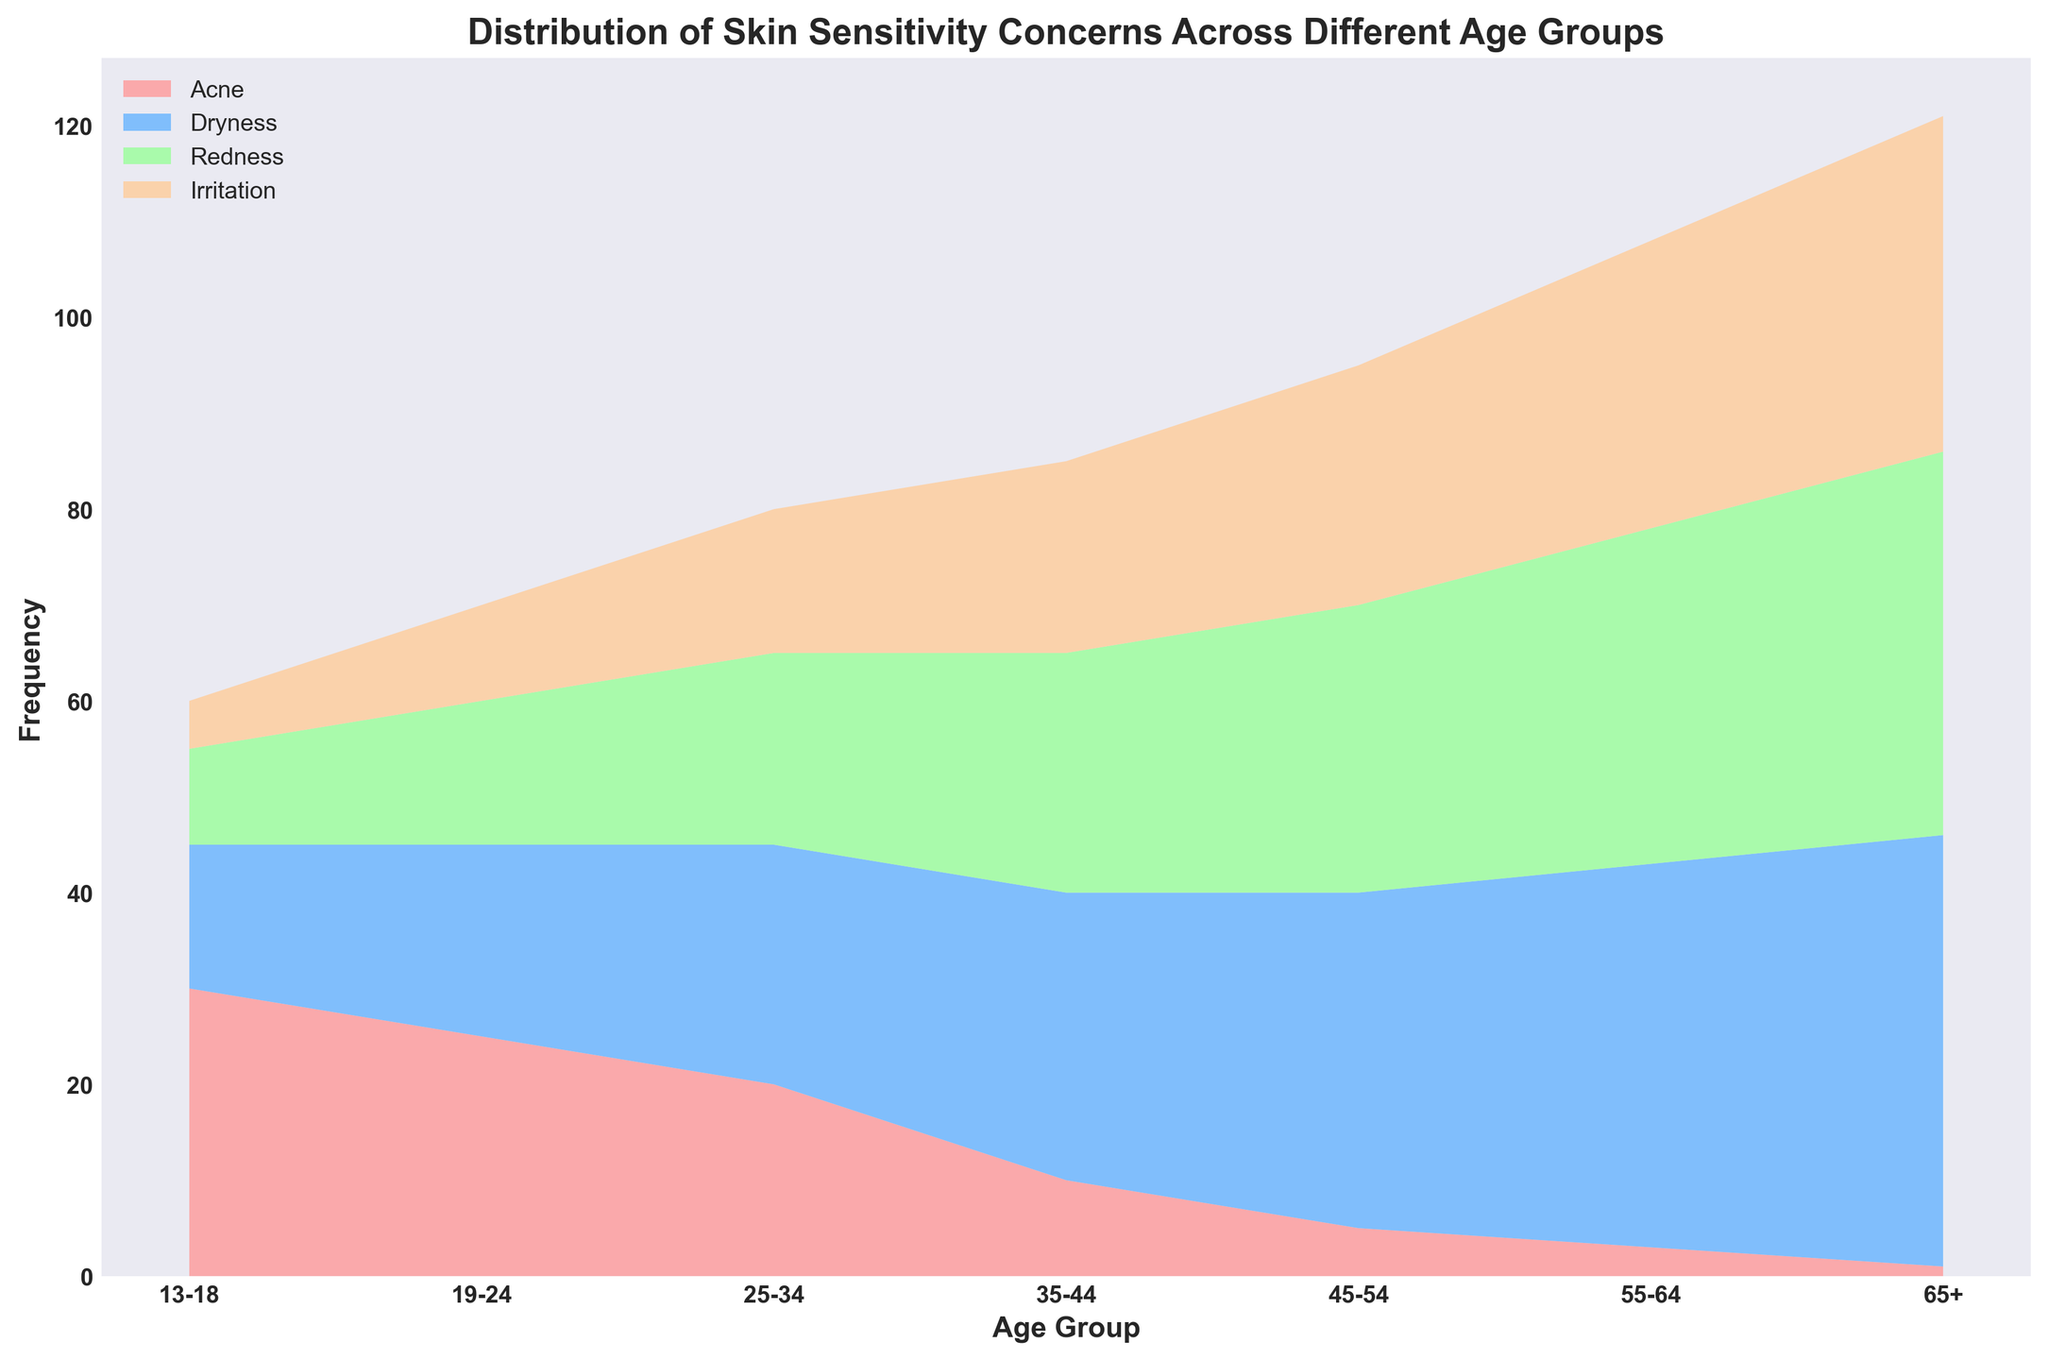What age group has the highest frequency of skin dryness concerns? Examine the figure to identify the age group with the highest contribution to the dryness segment which is marked in blue. The age group with the peak in this area is "65+."
Answer: 65+ How does the frequency of acne concerns change across different age groups? Look at the red-colored area in the figure, which represents acne. The height of this area decreases steadily from the 13-18 age group to the 65+ age group.
Answer: Decreases Which skin sensitivity concern is most prevalent in the 25-34 age group? Check the figure for the highest point within the 25-34 age group. The largest segment is green, which corresponds to dryness.
Answer: Dryness In the 35-44 age group, is redness more common than acne? Compare the heights of the green (redness) and blue (acne) areas within the 35-44 age group. The green area is taller, indicating redness is more common.
Answer: Yes What's the total frequency of skin concerns for the 55-64 age group? Add the frequencies for acne (3), dryness (40), redness (35), and irritation (30) in the 55-64 age group: 3 + 40 + 35 + 30 = 108.
Answer: 108 Compare the frequency of acne concerns between the 13-18 age group and the 45-54 age group. The acne frequency in the 13-18 age group is 30, while in the 45-54 age group it is 5. Therefore, acne is much more prevalent in the 13-18 age group.
Answer: 13-18 > 45-54 Which age group has the lowest frequency of irritation concerns? Observe the orange area, which represents irritation. The smallest orange segment is in the 13-18 age group.
Answer: 13-18 How does the distribution of redness concerns change from the youngest to oldest age groups? The height of the green segment, representing redness, grows steadily from the youngest to the oldest age groups, showing an increase.
Answer: Increases Find the difference in the frequency of irritation concerns between the 35-44 and 65+ age groups. Irritation frequency in the 35-44 age group is 20, while in the 65+ age group it is 35. The difference is 35 - 20 = 15.
Answer: 15 Which age group shows the highest total frequency of skin sensitivity concerns? Sum the heights of all concern areas for each age group. The 65+ age group has the highest cumulative height due to consistent contributions from all concerns.
Answer: 65+ 